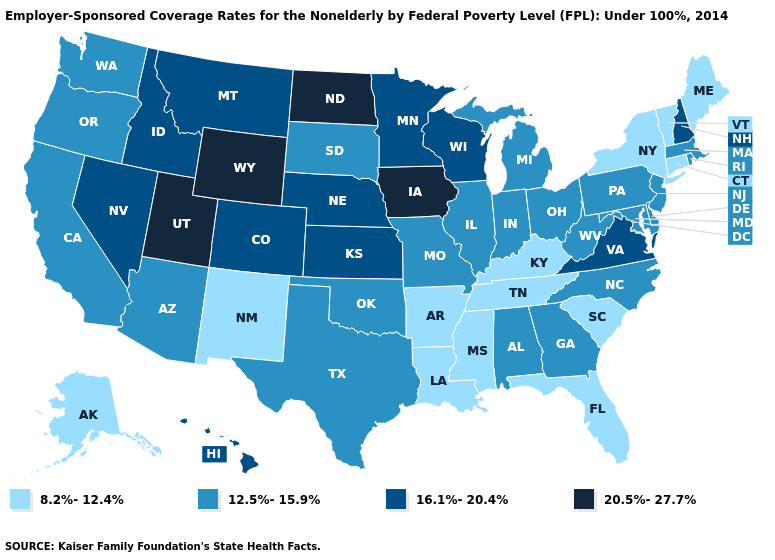Name the states that have a value in the range 16.1%-20.4%?
Be succinct. Colorado, Hawaii, Idaho, Kansas, Minnesota, Montana, Nebraska, Nevada, New Hampshire, Virginia, Wisconsin. Which states have the lowest value in the Northeast?
Quick response, please. Connecticut, Maine, New York, Vermont. Does South Carolina have the lowest value in the USA?
Concise answer only. Yes. What is the highest value in states that border Florida?
Short answer required. 12.5%-15.9%. Among the states that border Vermont , which have the highest value?
Short answer required. New Hampshire. What is the lowest value in states that border Nevada?
Write a very short answer. 12.5%-15.9%. Name the states that have a value in the range 8.2%-12.4%?
Short answer required. Alaska, Arkansas, Connecticut, Florida, Kentucky, Louisiana, Maine, Mississippi, New Mexico, New York, South Carolina, Tennessee, Vermont. What is the highest value in the Northeast ?
Short answer required. 16.1%-20.4%. Does the first symbol in the legend represent the smallest category?
Give a very brief answer. Yes. Is the legend a continuous bar?
Short answer required. No. Name the states that have a value in the range 12.5%-15.9%?
Write a very short answer. Alabama, Arizona, California, Delaware, Georgia, Illinois, Indiana, Maryland, Massachusetts, Michigan, Missouri, New Jersey, North Carolina, Ohio, Oklahoma, Oregon, Pennsylvania, Rhode Island, South Dakota, Texas, Washington, West Virginia. What is the value of Kansas?
Short answer required. 16.1%-20.4%. Does New York have the lowest value in the USA?
Write a very short answer. Yes. What is the lowest value in the USA?
Short answer required. 8.2%-12.4%. What is the lowest value in states that border Nebraska?
Short answer required. 12.5%-15.9%. 